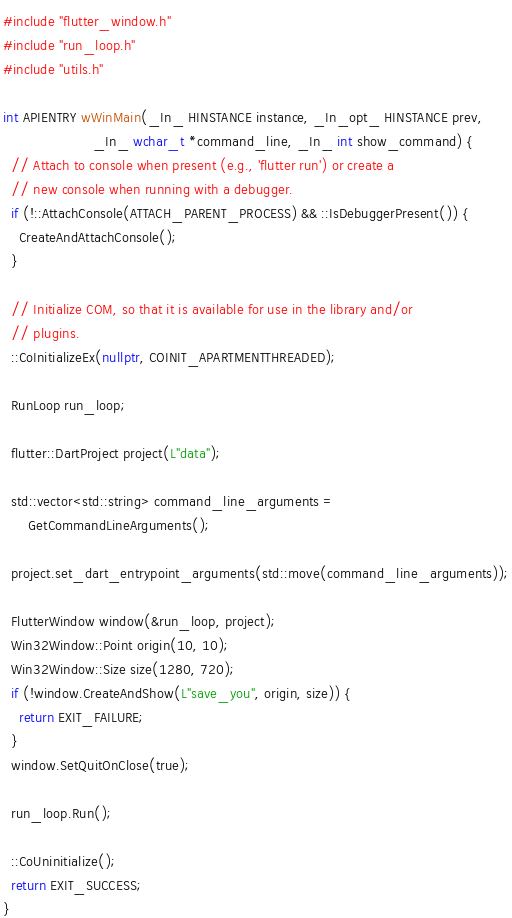<code> <loc_0><loc_0><loc_500><loc_500><_C++_>
#include "flutter_window.h"
#include "run_loop.h"
#include "utils.h"

int APIENTRY wWinMain(_In_ HINSTANCE instance, _In_opt_ HINSTANCE prev,
                      _In_ wchar_t *command_line, _In_ int show_command) {
  // Attach to console when present (e.g., 'flutter run') or create a
  // new console when running with a debugger.
  if (!::AttachConsole(ATTACH_PARENT_PROCESS) && ::IsDebuggerPresent()) {
    CreateAndAttachConsole();
  }

  // Initialize COM, so that it is available for use in the library and/or
  // plugins.
  ::CoInitializeEx(nullptr, COINIT_APARTMENTTHREADED);

  RunLoop run_loop;

  flutter::DartProject project(L"data");

  std::vector<std::string> command_line_arguments =
      GetCommandLineArguments();

  project.set_dart_entrypoint_arguments(std::move(command_line_arguments));

  FlutterWindow window(&run_loop, project);
  Win32Window::Point origin(10, 10);
  Win32Window::Size size(1280, 720);
  if (!window.CreateAndShow(L"save_you", origin, size)) {
    return EXIT_FAILURE;
  }
  window.SetQuitOnClose(true);

  run_loop.Run();

  ::CoUninitialize();
  return EXIT_SUCCESS;
}
</code> 